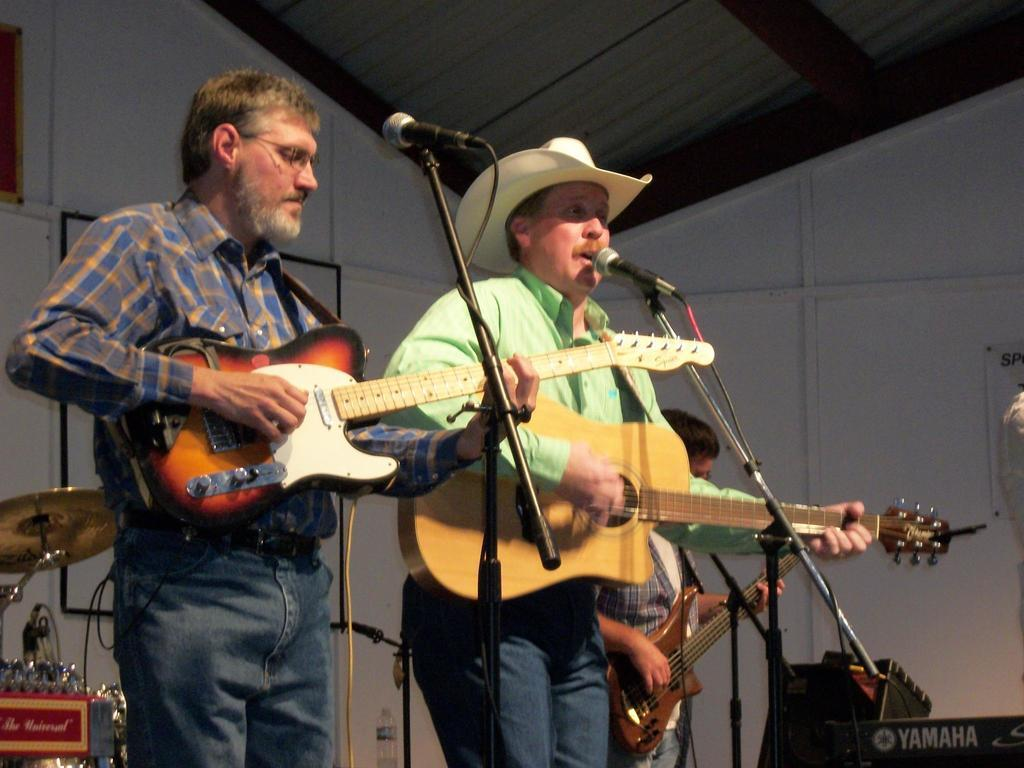How many people are in the image? There are three men in the image. What are the men doing in the image? The men are standing, playing guitars, and singing. What objects are present in the image that might be used for amplifying sound? Microphones are present in the image. What type of company is being advertised in the image? There is no company being advertised in the image; it features three men playing guitars and singing. What type of cable is connected to the microphones in the image? There is no cable connected to the microphones in the image; only the men, their guitars, and the microphones are present. 